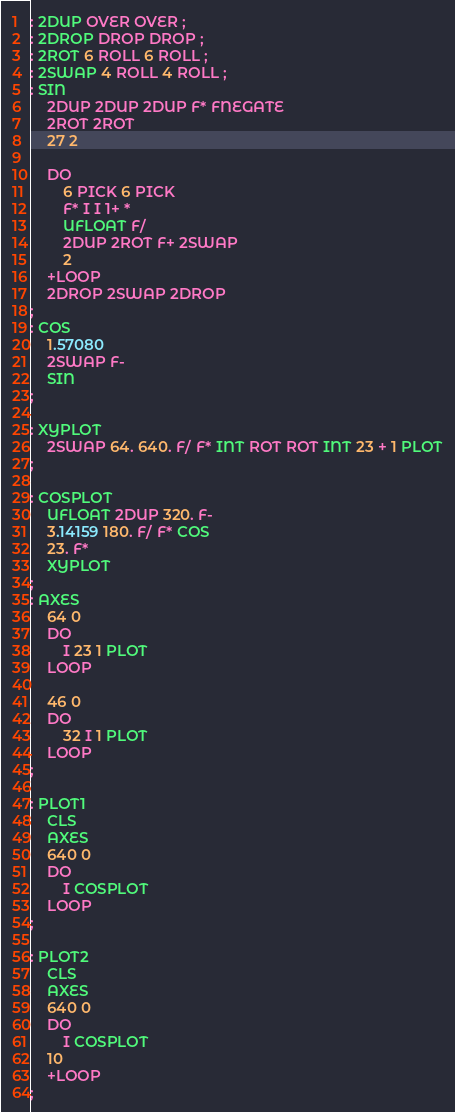Convert code to text. <code><loc_0><loc_0><loc_500><loc_500><_Forth_>: 2DUP OVER OVER ;
: 2DROP DROP DROP ;
: 2ROT 6 ROLL 6 ROLL ;
: 2SWAP 4 ROLL 4 ROLL ;
: SIN
    2DUP 2DUP 2DUP F* FNEGATE
    2ROT 2ROT
    27 2

    DO
        6 PICK 6 PICK
        F* I I 1+ *
        UFLOAT F/
        2DUP 2ROT F+ 2SWAP
        2
    +LOOP
    2DROP 2SWAP 2DROP
;
: COS
    1.57080
    2SWAP F-
    SIN
;

: XYPLOT
    2SWAP 64. 640. F/ F* INT ROT ROT INT 23 + 1 PLOT
;

: COSPLOT
    UFLOAT 2DUP 320. F-
    3.14159 180. F/ F* COS
    23. F*
    XYPLOT
;
: AXES
    64 0
    DO
        I 23 1 PLOT
    LOOP

    46 0  
    DO
        32 I 1 PLOT
    LOOP 
;

: PLOT1 
    CLS
    AXES
    640 0
    DO
        I COSPLOT
    LOOP
;

: PLOT2
    CLS
    AXES
    640 0
    DO
        I COSPLOT
    10
    +LOOP
;</code> 